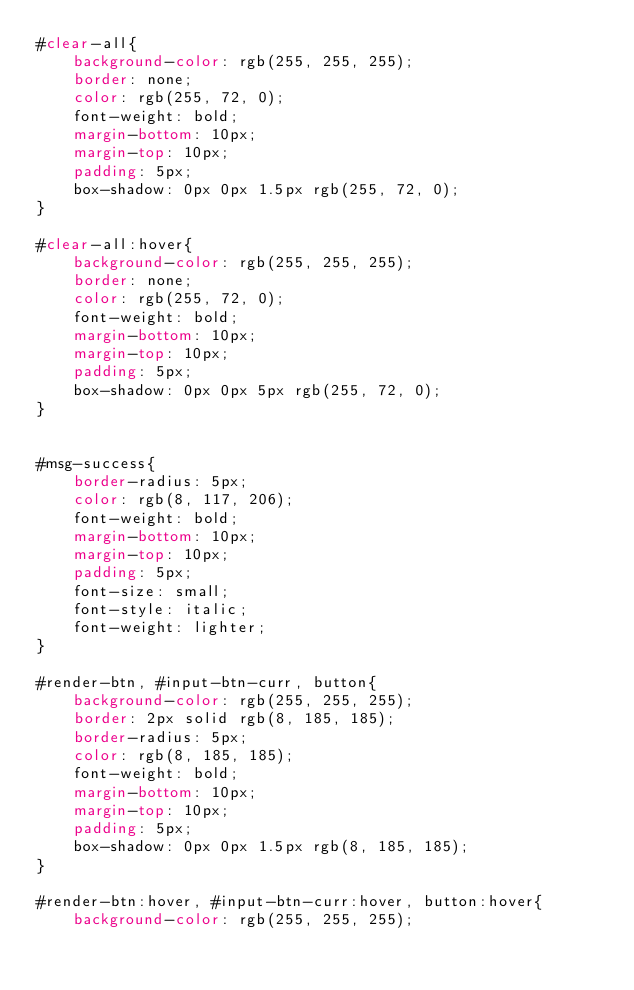Convert code to text. <code><loc_0><loc_0><loc_500><loc_500><_CSS_>#clear-all{
    background-color: rgb(255, 255, 255);
    border: none;
    color: rgb(255, 72, 0);
    font-weight: bold;
    margin-bottom: 10px;
    margin-top: 10px;
    padding: 5px;
    box-shadow: 0px 0px 1.5px rgb(255, 72, 0);
}

#clear-all:hover{
    background-color: rgb(255, 255, 255);
    border: none;
    color: rgb(255, 72, 0);
    font-weight: bold;
    margin-bottom: 10px;
    margin-top: 10px;
    padding: 5px;
    box-shadow: 0px 0px 5px rgb(255, 72, 0);
}


#msg-success{
    border-radius: 5px;
    color: rgb(8, 117, 206);
    font-weight: bold;
    margin-bottom: 10px;
    margin-top: 10px;
    padding: 5px;
    font-size: small;
    font-style: italic;
    font-weight: lighter;
}

#render-btn, #input-btn-curr, button{
    background-color: rgb(255, 255, 255);
    border: 2px solid rgb(8, 185, 185);
    border-radius: 5px;
    color: rgb(8, 185, 185);
    font-weight: bold;
    margin-bottom: 10px;
    margin-top: 10px;
    padding: 5px;
    box-shadow: 0px 0px 1.5px rgb(8, 185, 185);
}

#render-btn:hover, #input-btn-curr:hover, button:hover{
    background-color: rgb(255, 255, 255);</code> 